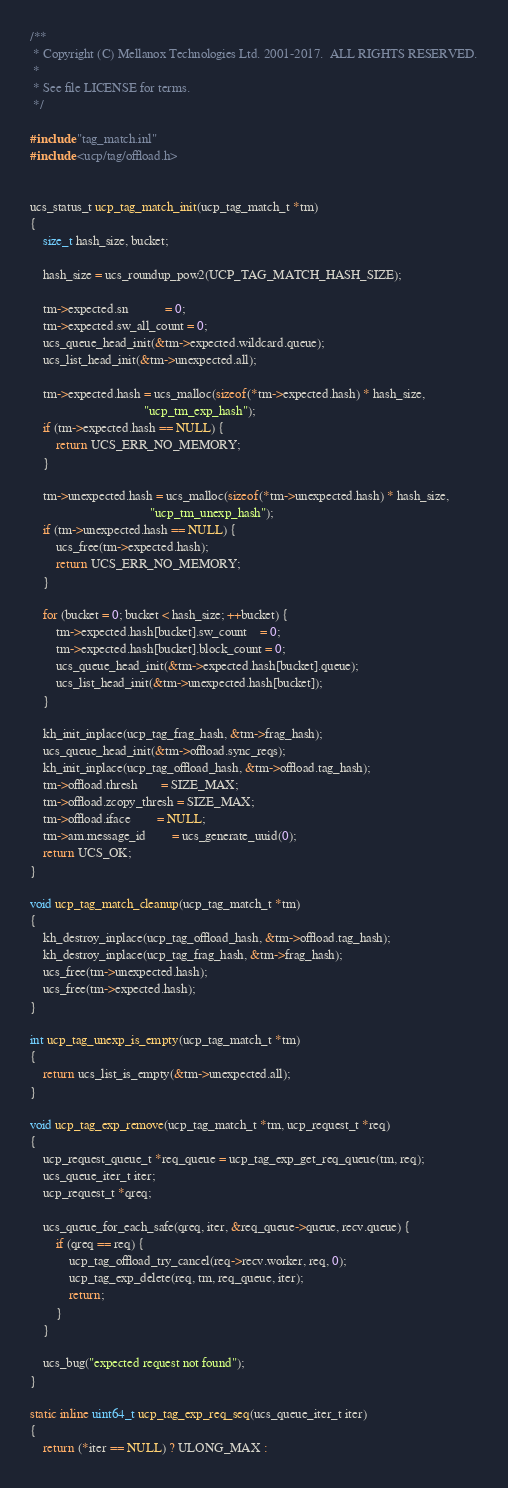Convert code to text. <code><loc_0><loc_0><loc_500><loc_500><_C_>/**
 * Copyright (C) Mellanox Technologies Ltd. 2001-2017.  ALL RIGHTS RESERVED.
 *
 * See file LICENSE for terms.
 */

#include "tag_match.inl"
#include <ucp/tag/offload.h>


ucs_status_t ucp_tag_match_init(ucp_tag_match_t *tm)
{
    size_t hash_size, bucket;

    hash_size = ucs_roundup_pow2(UCP_TAG_MATCH_HASH_SIZE);

    tm->expected.sn           = 0;
    tm->expected.sw_all_count = 0;
    ucs_queue_head_init(&tm->expected.wildcard.queue);
    ucs_list_head_init(&tm->unexpected.all);

    tm->expected.hash = ucs_malloc(sizeof(*tm->expected.hash) * hash_size,
                                   "ucp_tm_exp_hash");
    if (tm->expected.hash == NULL) {
        return UCS_ERR_NO_MEMORY;
    }

    tm->unexpected.hash = ucs_malloc(sizeof(*tm->unexpected.hash) * hash_size,
                                     "ucp_tm_unexp_hash");
    if (tm->unexpected.hash == NULL) {
        ucs_free(tm->expected.hash);
        return UCS_ERR_NO_MEMORY;
    }

    for (bucket = 0; bucket < hash_size; ++bucket) {
        tm->expected.hash[bucket].sw_count    = 0;
        tm->expected.hash[bucket].block_count = 0;
        ucs_queue_head_init(&tm->expected.hash[bucket].queue);
        ucs_list_head_init(&tm->unexpected.hash[bucket]);
    }

    kh_init_inplace(ucp_tag_frag_hash, &tm->frag_hash);
    ucs_queue_head_init(&tm->offload.sync_reqs);
    kh_init_inplace(ucp_tag_offload_hash, &tm->offload.tag_hash);
    tm->offload.thresh       = SIZE_MAX;
    tm->offload.zcopy_thresh = SIZE_MAX;
    tm->offload.iface        = NULL;
    tm->am.message_id        = ucs_generate_uuid(0);
    return UCS_OK;
}

void ucp_tag_match_cleanup(ucp_tag_match_t *tm)
{
    kh_destroy_inplace(ucp_tag_offload_hash, &tm->offload.tag_hash);
    kh_destroy_inplace(ucp_tag_frag_hash, &tm->frag_hash);
    ucs_free(tm->unexpected.hash);
    ucs_free(tm->expected.hash);
}

int ucp_tag_unexp_is_empty(ucp_tag_match_t *tm)
{
    return ucs_list_is_empty(&tm->unexpected.all);
}

void ucp_tag_exp_remove(ucp_tag_match_t *tm, ucp_request_t *req)
{
    ucp_request_queue_t *req_queue = ucp_tag_exp_get_req_queue(tm, req);
    ucs_queue_iter_t iter;
    ucp_request_t *qreq;

    ucs_queue_for_each_safe(qreq, iter, &req_queue->queue, recv.queue) {
        if (qreq == req) {
            ucp_tag_offload_try_cancel(req->recv.worker, req, 0);
            ucp_tag_exp_delete(req, tm, req_queue, iter);
            return;
        }
    }

    ucs_bug("expected request not found");
}

static inline uint64_t ucp_tag_exp_req_seq(ucs_queue_iter_t iter)
{
    return (*iter == NULL) ? ULONG_MAX :</code> 